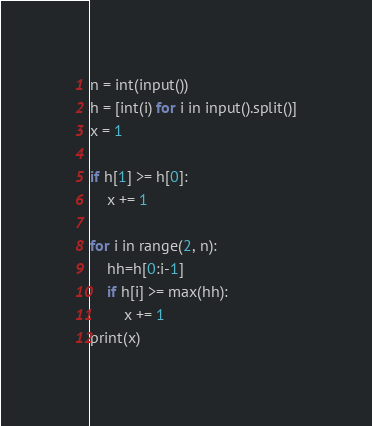<code> <loc_0><loc_0><loc_500><loc_500><_Python_>n = int(input())
h = [int(i) for i in input().split()]
x = 1

if h[1] >= h[0]:
	x += 1

for i in range(2, n):
    hh=h[0:i-1]
    if h[i] >= max(hh):
        x += 1
print(x)</code> 